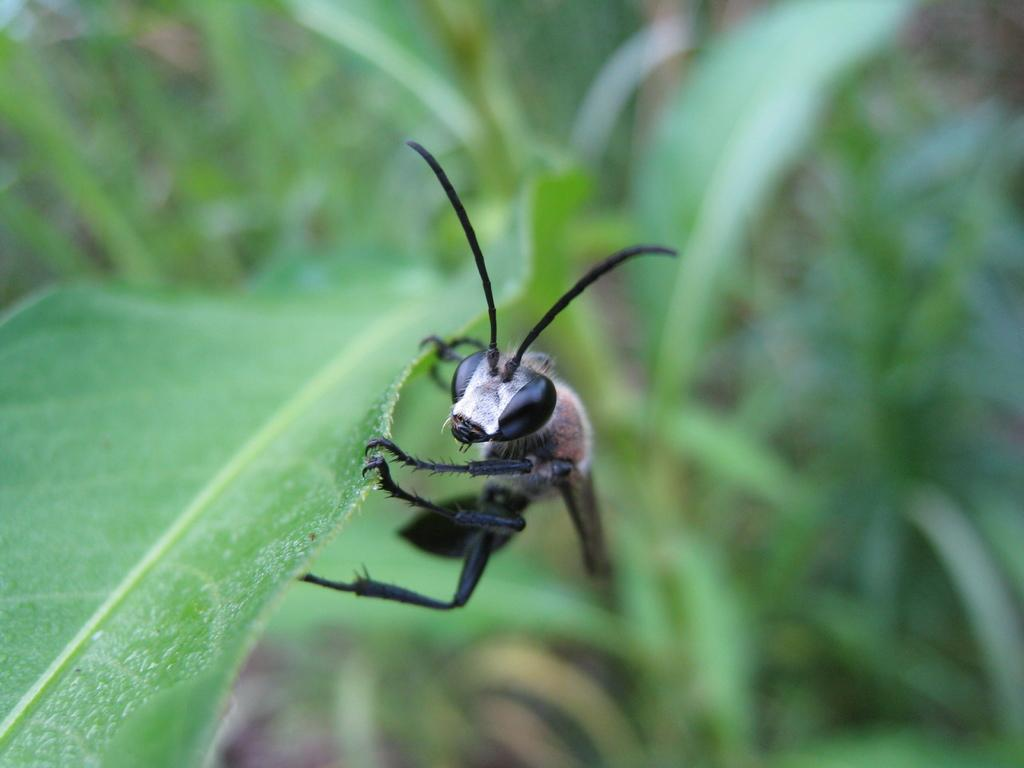What is present in the image? There is an insect in the image. Where is the insect located? The insect is on a leaf. What type of bushes can be seen in the image? There is no mention of bushes in the provided facts, so we cannot determine if they are present in the image. Is there any steam visible in the image? There is no mention of steam in the provided facts, so we cannot determine if it is present in the image. 